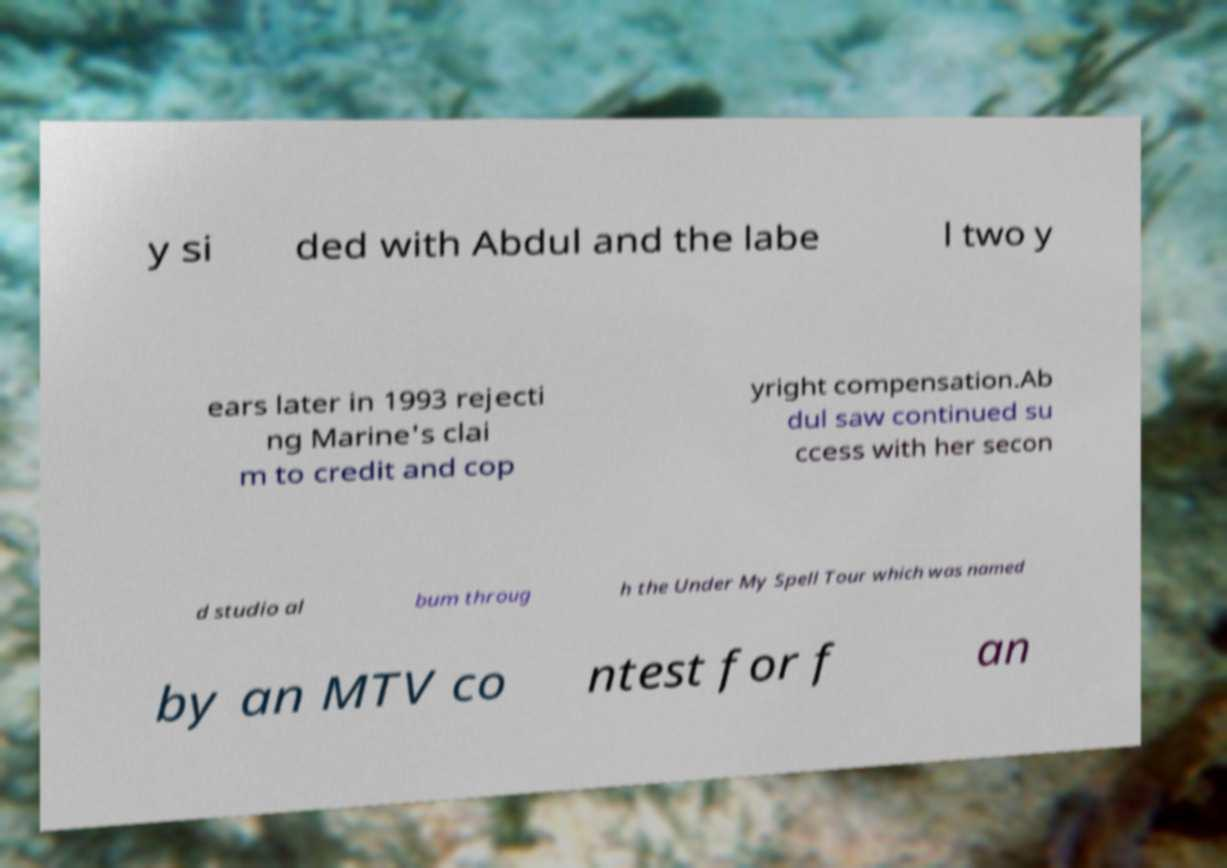Please read and relay the text visible in this image. What does it say? y si ded with Abdul and the labe l two y ears later in 1993 rejecti ng Marine's clai m to credit and cop yright compensation.Ab dul saw continued su ccess with her secon d studio al bum throug h the Under My Spell Tour which was named by an MTV co ntest for f an 